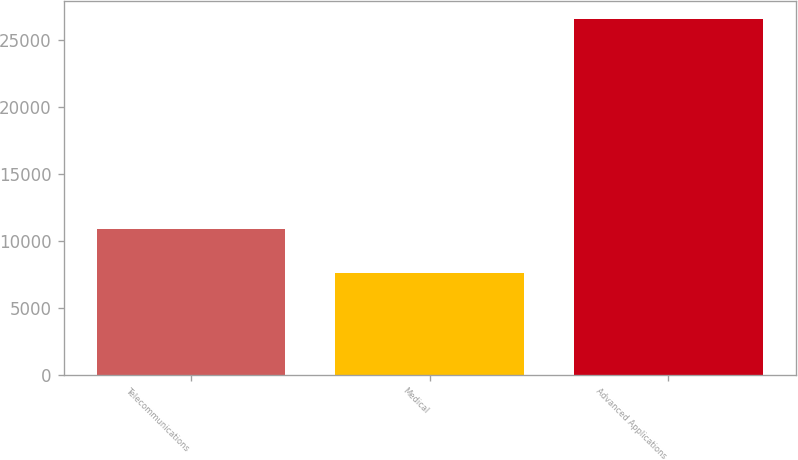Convert chart to OTSL. <chart><loc_0><loc_0><loc_500><loc_500><bar_chart><fcel>Telecommunications<fcel>Medical<fcel>Advanced Applications<nl><fcel>10867<fcel>7606<fcel>26557<nl></chart> 